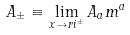<formula> <loc_0><loc_0><loc_500><loc_500>A _ { \pm } \equiv \lim _ { x \to r i ^ { \pm } } A _ { a } m ^ { a }</formula> 